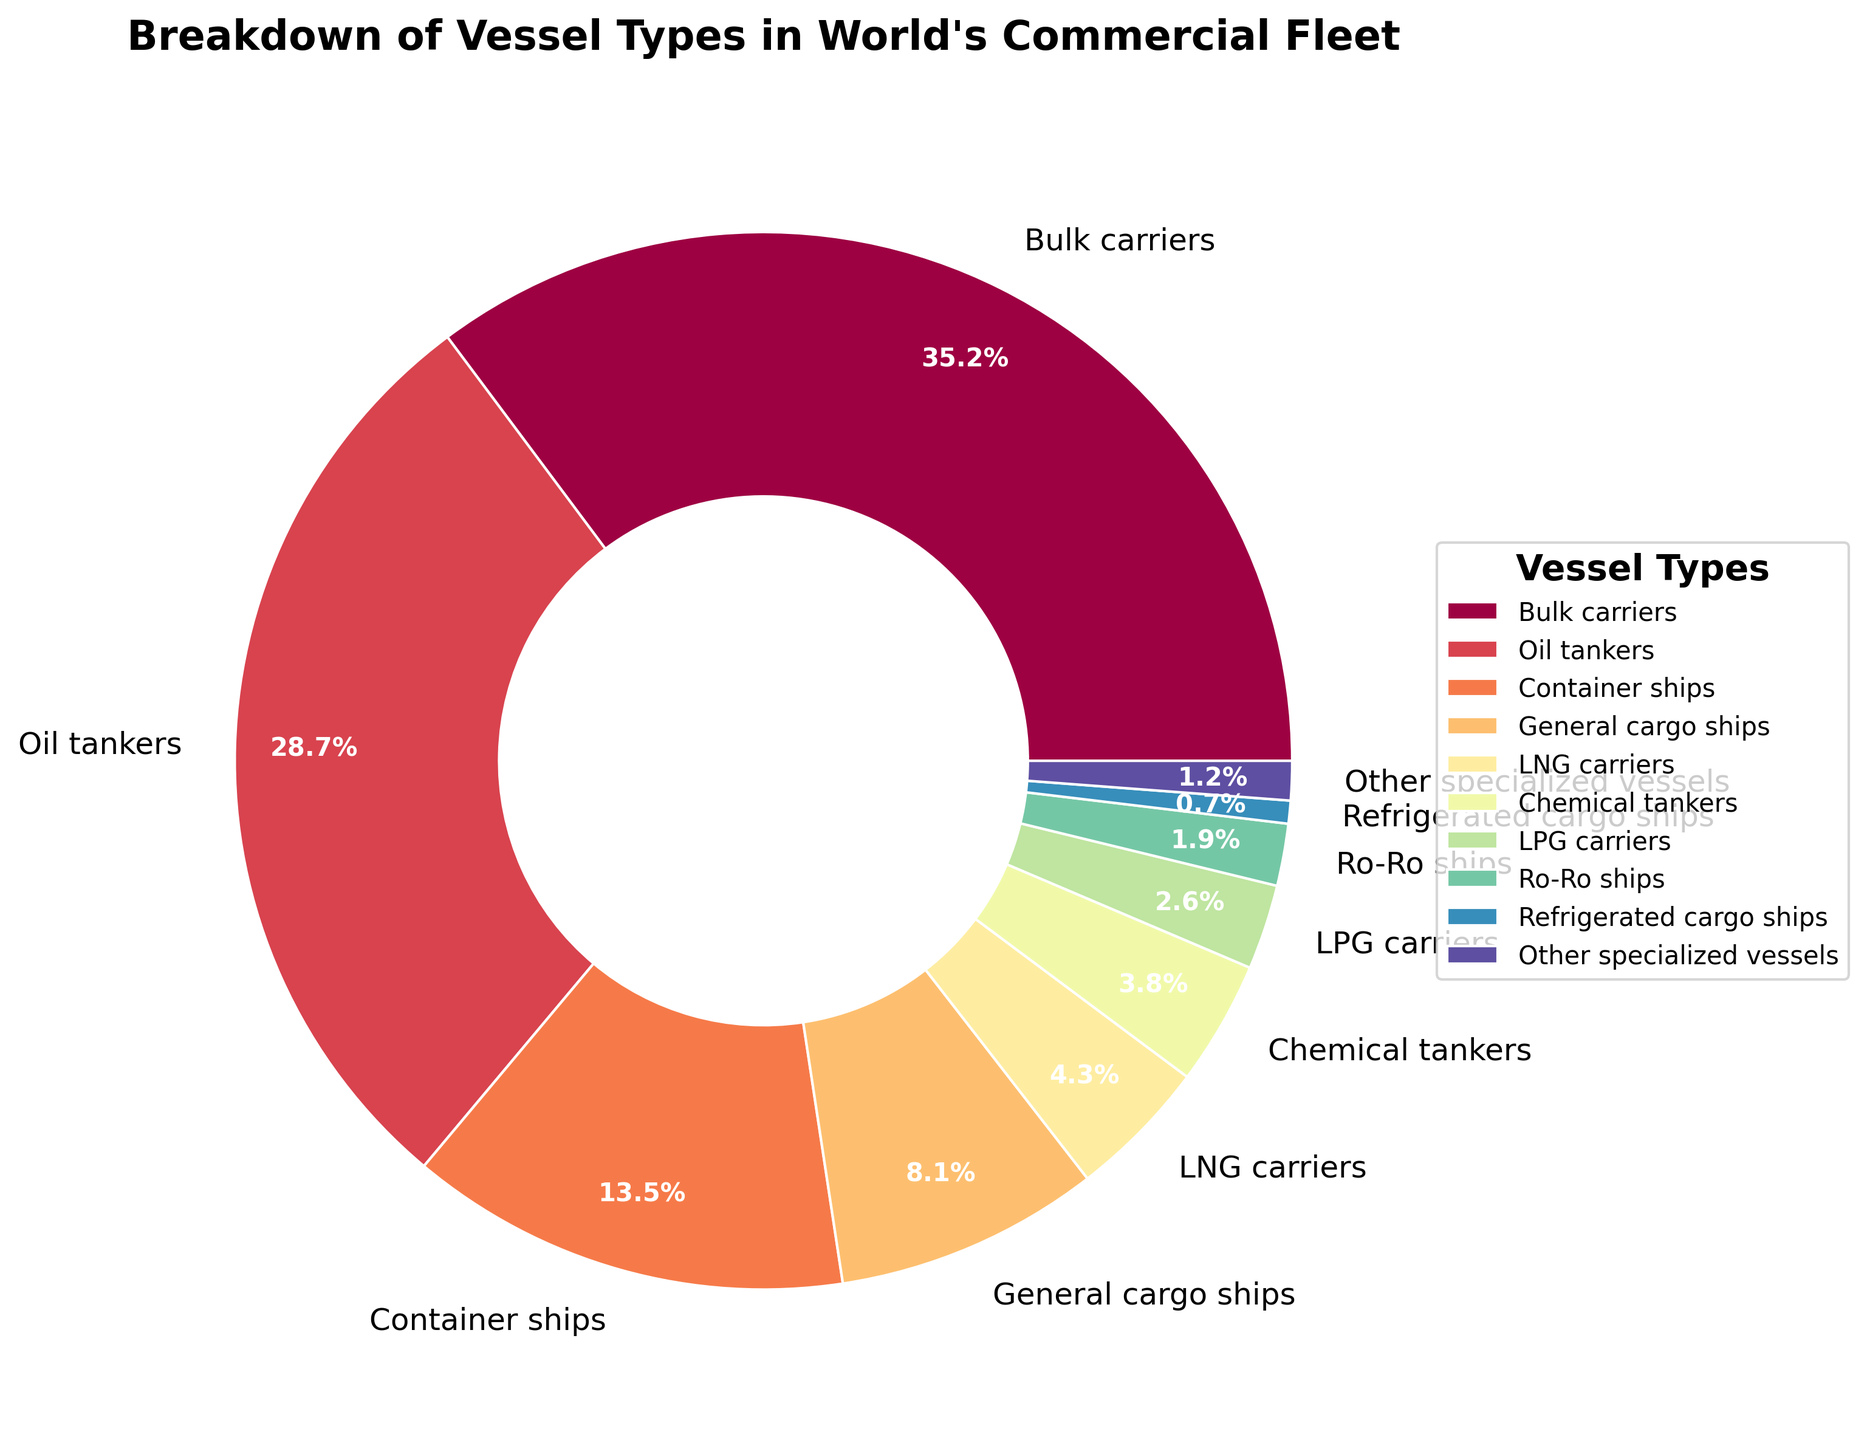What is the percentage of Bulk carriers? Bulk carriers occupy the largest portion of the pie chart. By referring to the segment labeled "Bulk carriers," you can see that it represents 35.2% of the world's commercial fleet by tonnage.
Answer: 35.2% What vessel type accounts for the second largest percentage? The segment next to Bulk carriers is labeled "Oil tankers," and its segment is the second largest. By observing the percentage labeled for "Oil tankers," you can confirm it accounts for 28.7%.
Answer: Oil tankers How much larger is the percentage of Bulk carriers compared to Container ships? Bulk carriers occupy 35.2%, and Container ships occupy 13.5%. The difference can be calculated as 35.2% - 13.5% = 21.7%.
Answer: 21.7% What is the total percentage of vessel types that are tankers (Oil tankers, Chemical tankers, and LNG carriers)? Combine the percentages of Oil tankers (28.7%), Chemical tankers (3.8%), and LNG carriers (4.3%). The total is 28.7% + 3.8% + 4.3% = 36.8%.
Answer: 36.8% How does the percentage of General cargo ships compare to Ro-Ro ships? General cargo ships have a percentage of 8.1%, while Ro-Ro ships have a percentage of 1.9%. By comparing the two, general cargo ships represent a larger portion.
Answer: General cargo ships have a larger percentage Which vessel type has the smallest percentage? By examining the smallest segment in the pie chart, you can identify "Refrigerated cargo ships," which have a percentage of 0.7%.
Answer: Refrigerated cargo ships Are Bulk carriers and Oil tankers together more than half of the world's commercial fleet? Sum the percentages of Bulk carriers (35.2%) and Oil tankers (28.7%), which equals 63.9%. Since 63.9% is more than 50%, together, they account for more than half.
Answer: Yes What is the combined percentage of all vessel types not classified as Bulk carriers or Oil tankers? Subtract the combined percentage of Bulk carriers and Oil tankers (35.2% + 28.7% = 63.9%) from 100%. The combined percentage for the other vessel types is 100% - 63.9% = 36.1%.
Answer: 36.1% 